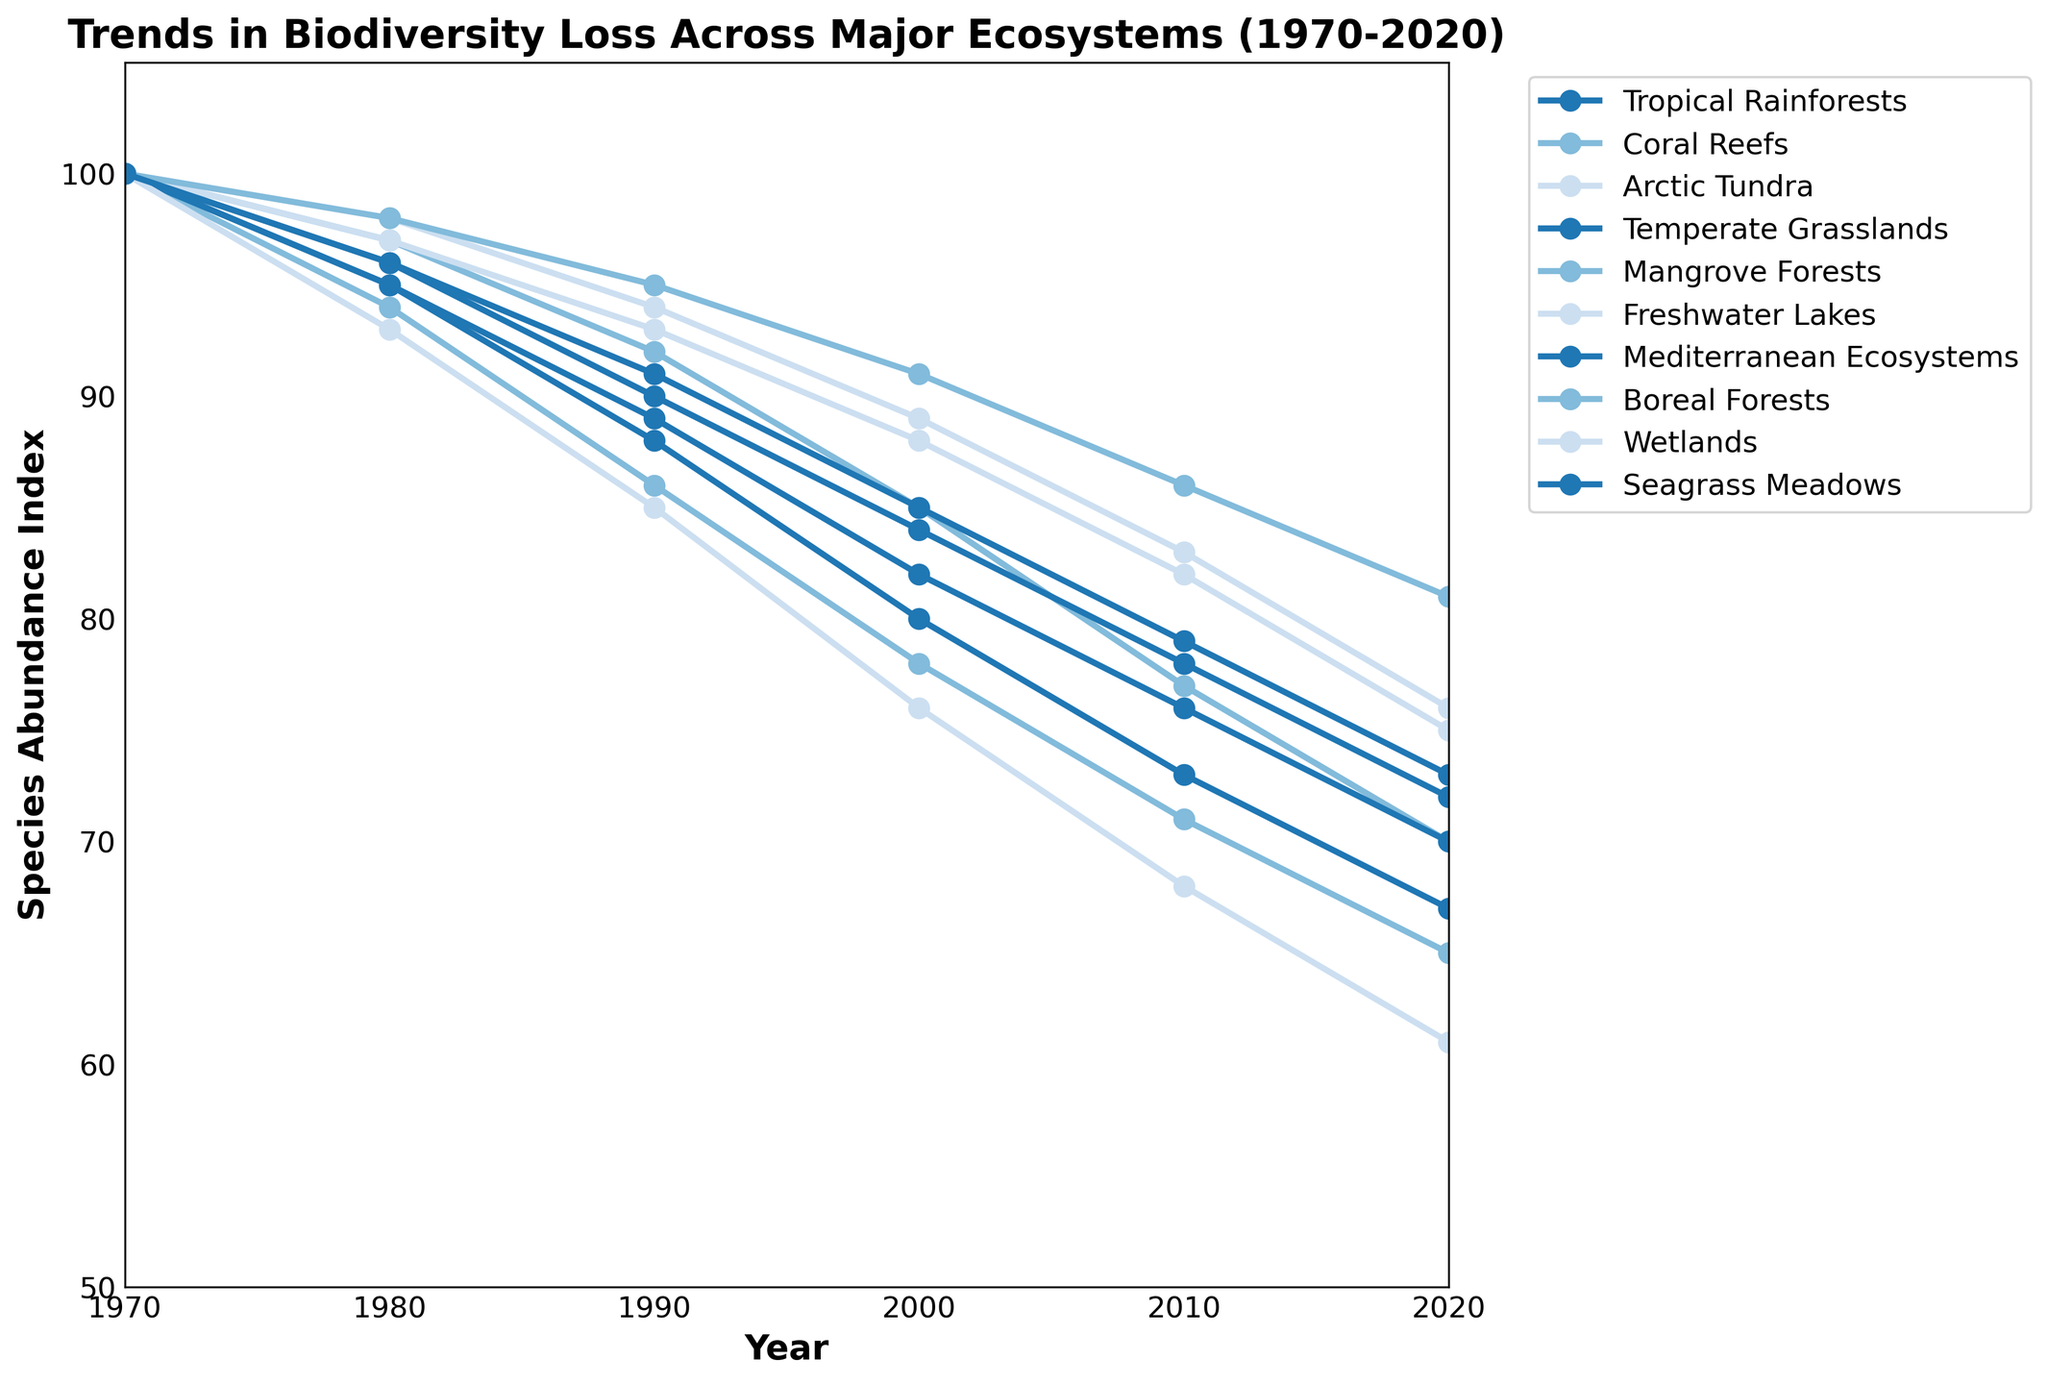What is the general trend in species abundance across ecosystems from 1970 to 2020? The general trend shows a decrease in species abundance over time for all ecosystems. By looking at the lines for each ecosystem, they all slope downward from left (1970) to right (2020).
Answer: Decreasing Which ecosystem experienced the greatest decline in species abundance from 1970 to 2020? To find the greatest decline, we need to compare the differences between the 1970 and 2020 values for each ecosystem. Wetlands decrease by 39 (100 to 61). This is the largest decrease among the ecosystems.
Answer: Wetlands Which ecosystem showed the smallest decrease in species abundance from 1970 to 2020? To find the smallest decline, we compare the differences between the 1970 and 2020 values for each ecosystem. Arctic Tundra has a decrease of 24 (100 to 76), which is the smallest decrease.
Answer: Arctic Tundra How did the species abundance in Coral Reefs change between 1980 and 2020? The species abundance in Coral Reefs was 97 in 1980 and decreased to 70 in 2020. The difference is 97 - 70 = 27. Thus, there was a decline of 27.
Answer: Declined by 27 What was the average species abundance across all ecosystems in 2020? To find the average species abundance in 2020, sum the values for all ecosystems in 2020 and divide by the number of ecosystems. (67 + 70 + 76 + 72 + 65 + 75 + 70 + 81 + 61 + 73) / 10 = 73
Answer: 73 Which ecosystem had a species abundance of 95 in the year 1980? By checking the values for the year 1980, Tropical Rainforests and Mediterranean Ecosystems both had a species abundance of 95.
Answer: Tropical Rainforests and Mediterranean Ecosystems By how much did the species abundance in Seagrass Meadows change between 1990 and 2000? Check the values for Seagrass Meadows in 1990 and 2000. The values are 91 and 85 respectively. The difference is 91 - 85 = 6. Thus, there was a decline of 6.
Answer: Declined by 6 Which ecosystems had a species abundance below 70 in 2020? To find which ecosystems had a species abundance below 70 in 2020, we look at the 2020 column. Wetlands (61), Mangrove Forests (65), and Temperate Grasslands (72).
Answer: Wetlands, Mangrove Forests By how much did species abundance in Mangrove Forests decrease between 1970 and 2010? The species abundance in Mangrove Forests was 100 in 1970 and 71 in 2010. The difference is 100 - 71 = 29. Thus, there was a decline of 29.
Answer: Declined by 29 Which ecosystem had a higher species abundance in 2010: Freshwater Lakes or Boreal Forests? By checking the values for 2010, Freshwater Lakes had a species abundance of 82 while Boreal Forests had a species abundance of 86. Thus, Boreal Forests had a higher species abundance.
Answer: Boreal Forests 